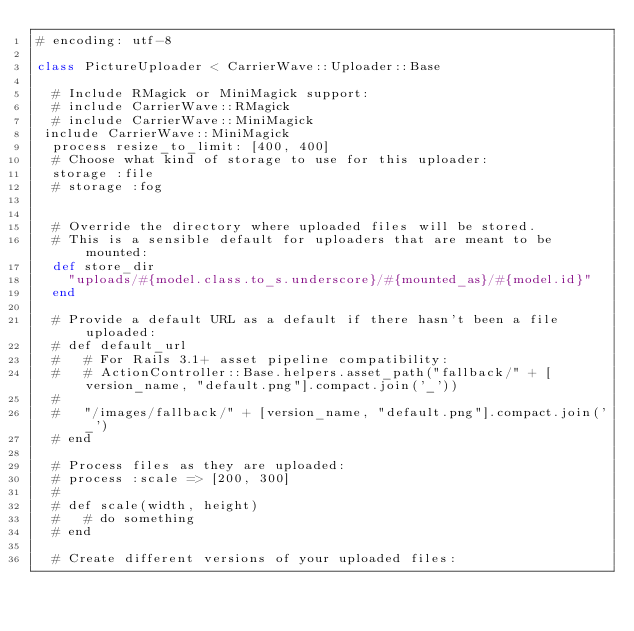<code> <loc_0><loc_0><loc_500><loc_500><_Ruby_># encoding: utf-8

class PictureUploader < CarrierWave::Uploader::Base

  # Include RMagick or MiniMagick support:
  # include CarrierWave::RMagick
  # include CarrierWave::MiniMagick
 include CarrierWave::MiniMagick
  process resize_to_limit: [400, 400]
  # Choose what kind of storage to use for this uploader:
  storage :file
  # storage :fog
 

  # Override the directory where uploaded files will be stored.
  # This is a sensible default for uploaders that are meant to be mounted:
  def store_dir
    "uploads/#{model.class.to_s.underscore}/#{mounted_as}/#{model.id}"
  end

  # Provide a default URL as a default if there hasn't been a file uploaded:
  # def default_url
  #   # For Rails 3.1+ asset pipeline compatibility:
  #   # ActionController::Base.helpers.asset_path("fallback/" + [version_name, "default.png"].compact.join('_'))
  #
  #   "/images/fallback/" + [version_name, "default.png"].compact.join('_')
  # end

  # Process files as they are uploaded:
  # process :scale => [200, 300]
  #
  # def scale(width, height)
  #   # do something
  # end

  # Create different versions of your uploaded files:</code> 